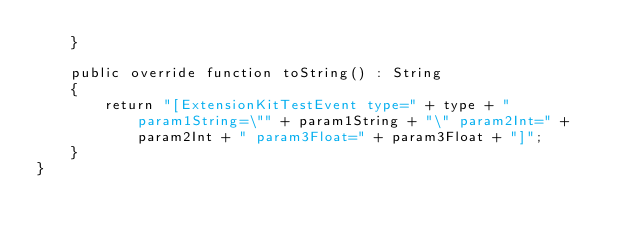Convert code to text. <code><loc_0><loc_0><loc_500><loc_500><_Haxe_>	}

	public override function toString() : String
    {
		return "[ExtensionKitTestEvent type=" + type + " param1String=\"" + param1String + "\" param2Int=" + param2Int + " param3Float=" + param3Float + "]";
	}
}</code> 